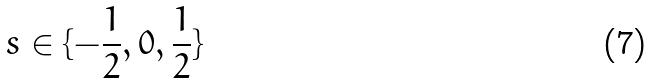Convert formula to latex. <formula><loc_0><loc_0><loc_500><loc_500>s \in \{ - \frac { 1 } { 2 } , 0 , \frac { 1 } { 2 } \}</formula> 